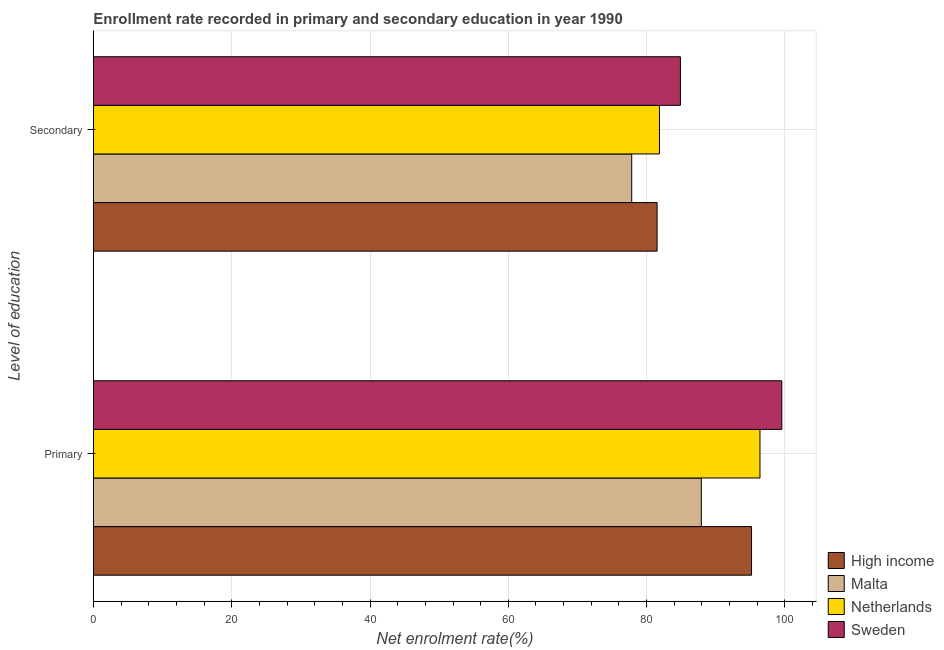How many different coloured bars are there?
Your answer should be compact. 4. Are the number of bars per tick equal to the number of legend labels?
Provide a short and direct response. Yes. Are the number of bars on each tick of the Y-axis equal?
Make the answer very short. Yes. How many bars are there on the 1st tick from the top?
Offer a terse response. 4. What is the label of the 2nd group of bars from the top?
Offer a terse response. Primary. What is the enrollment rate in primary education in Netherlands?
Keep it short and to the point. 96.4. Across all countries, what is the maximum enrollment rate in secondary education?
Provide a short and direct response. 84.89. Across all countries, what is the minimum enrollment rate in secondary education?
Offer a very short reply. 77.85. In which country was the enrollment rate in primary education maximum?
Your answer should be compact. Sweden. In which country was the enrollment rate in primary education minimum?
Provide a short and direct response. Malta. What is the total enrollment rate in primary education in the graph?
Offer a very short reply. 379.05. What is the difference between the enrollment rate in primary education in Malta and that in High income?
Provide a short and direct response. -7.27. What is the difference between the enrollment rate in primary education in High income and the enrollment rate in secondary education in Netherlands?
Provide a succinct answer. 13.32. What is the average enrollment rate in secondary education per country?
Give a very brief answer. 81.53. What is the difference between the enrollment rate in primary education and enrollment rate in secondary education in Malta?
Offer a terse response. 10.06. In how many countries, is the enrollment rate in secondary education greater than 68 %?
Make the answer very short. 4. What is the ratio of the enrollment rate in secondary education in High income to that in Sweden?
Make the answer very short. 0.96. Is the enrollment rate in secondary education in Malta less than that in High income?
Your response must be concise. Yes. In how many countries, is the enrollment rate in primary education greater than the average enrollment rate in primary education taken over all countries?
Ensure brevity in your answer.  3. What does the 1st bar from the bottom in Primary represents?
Your answer should be compact. High income. Are the values on the major ticks of X-axis written in scientific E-notation?
Offer a very short reply. No. Does the graph contain any zero values?
Give a very brief answer. No. Where does the legend appear in the graph?
Your answer should be very brief. Bottom right. How many legend labels are there?
Provide a short and direct response. 4. How are the legend labels stacked?
Make the answer very short. Vertical. What is the title of the graph?
Your answer should be very brief. Enrollment rate recorded in primary and secondary education in year 1990. Does "Bahamas" appear as one of the legend labels in the graph?
Your answer should be compact. No. What is the label or title of the X-axis?
Ensure brevity in your answer.  Net enrolment rate(%). What is the label or title of the Y-axis?
Make the answer very short. Level of education. What is the Net enrolment rate(%) of High income in Primary?
Keep it short and to the point. 95.18. What is the Net enrolment rate(%) of Malta in Primary?
Ensure brevity in your answer.  87.91. What is the Net enrolment rate(%) of Netherlands in Primary?
Your response must be concise. 96.4. What is the Net enrolment rate(%) in Sweden in Primary?
Provide a succinct answer. 99.56. What is the Net enrolment rate(%) in High income in Secondary?
Provide a succinct answer. 81.52. What is the Net enrolment rate(%) of Malta in Secondary?
Your answer should be very brief. 77.85. What is the Net enrolment rate(%) of Netherlands in Secondary?
Provide a succinct answer. 81.86. What is the Net enrolment rate(%) of Sweden in Secondary?
Your response must be concise. 84.89. Across all Level of education, what is the maximum Net enrolment rate(%) in High income?
Your answer should be compact. 95.18. Across all Level of education, what is the maximum Net enrolment rate(%) of Malta?
Provide a short and direct response. 87.91. Across all Level of education, what is the maximum Net enrolment rate(%) in Netherlands?
Your answer should be compact. 96.4. Across all Level of education, what is the maximum Net enrolment rate(%) in Sweden?
Your answer should be compact. 99.56. Across all Level of education, what is the minimum Net enrolment rate(%) in High income?
Offer a very short reply. 81.52. Across all Level of education, what is the minimum Net enrolment rate(%) in Malta?
Make the answer very short. 77.85. Across all Level of education, what is the minimum Net enrolment rate(%) of Netherlands?
Offer a very short reply. 81.86. Across all Level of education, what is the minimum Net enrolment rate(%) of Sweden?
Make the answer very short. 84.89. What is the total Net enrolment rate(%) in High income in the graph?
Offer a very short reply. 176.7. What is the total Net enrolment rate(%) of Malta in the graph?
Your answer should be compact. 165.76. What is the total Net enrolment rate(%) in Netherlands in the graph?
Ensure brevity in your answer.  178.26. What is the total Net enrolment rate(%) in Sweden in the graph?
Provide a succinct answer. 184.45. What is the difference between the Net enrolment rate(%) in High income in Primary and that in Secondary?
Provide a succinct answer. 13.66. What is the difference between the Net enrolment rate(%) of Malta in Primary and that in Secondary?
Your answer should be compact. 10.06. What is the difference between the Net enrolment rate(%) in Netherlands in Primary and that in Secondary?
Your answer should be compact. 14.54. What is the difference between the Net enrolment rate(%) of Sweden in Primary and that in Secondary?
Offer a very short reply. 14.66. What is the difference between the Net enrolment rate(%) of High income in Primary and the Net enrolment rate(%) of Malta in Secondary?
Offer a terse response. 17.33. What is the difference between the Net enrolment rate(%) of High income in Primary and the Net enrolment rate(%) of Netherlands in Secondary?
Provide a short and direct response. 13.32. What is the difference between the Net enrolment rate(%) in High income in Primary and the Net enrolment rate(%) in Sweden in Secondary?
Give a very brief answer. 10.29. What is the difference between the Net enrolment rate(%) in Malta in Primary and the Net enrolment rate(%) in Netherlands in Secondary?
Your answer should be very brief. 6.05. What is the difference between the Net enrolment rate(%) in Malta in Primary and the Net enrolment rate(%) in Sweden in Secondary?
Offer a terse response. 3.02. What is the difference between the Net enrolment rate(%) in Netherlands in Primary and the Net enrolment rate(%) in Sweden in Secondary?
Keep it short and to the point. 11.5. What is the average Net enrolment rate(%) of High income per Level of education?
Make the answer very short. 88.35. What is the average Net enrolment rate(%) of Malta per Level of education?
Provide a short and direct response. 82.88. What is the average Net enrolment rate(%) of Netherlands per Level of education?
Give a very brief answer. 89.13. What is the average Net enrolment rate(%) of Sweden per Level of education?
Your answer should be very brief. 92.23. What is the difference between the Net enrolment rate(%) in High income and Net enrolment rate(%) in Malta in Primary?
Make the answer very short. 7.27. What is the difference between the Net enrolment rate(%) in High income and Net enrolment rate(%) in Netherlands in Primary?
Keep it short and to the point. -1.22. What is the difference between the Net enrolment rate(%) in High income and Net enrolment rate(%) in Sweden in Primary?
Your answer should be very brief. -4.38. What is the difference between the Net enrolment rate(%) in Malta and Net enrolment rate(%) in Netherlands in Primary?
Ensure brevity in your answer.  -8.48. What is the difference between the Net enrolment rate(%) in Malta and Net enrolment rate(%) in Sweden in Primary?
Your response must be concise. -11.64. What is the difference between the Net enrolment rate(%) of Netherlands and Net enrolment rate(%) of Sweden in Primary?
Provide a succinct answer. -3.16. What is the difference between the Net enrolment rate(%) in High income and Net enrolment rate(%) in Malta in Secondary?
Your answer should be very brief. 3.67. What is the difference between the Net enrolment rate(%) of High income and Net enrolment rate(%) of Netherlands in Secondary?
Keep it short and to the point. -0.34. What is the difference between the Net enrolment rate(%) of High income and Net enrolment rate(%) of Sweden in Secondary?
Offer a terse response. -3.37. What is the difference between the Net enrolment rate(%) of Malta and Net enrolment rate(%) of Netherlands in Secondary?
Give a very brief answer. -4.01. What is the difference between the Net enrolment rate(%) of Malta and Net enrolment rate(%) of Sweden in Secondary?
Your response must be concise. -7.04. What is the difference between the Net enrolment rate(%) of Netherlands and Net enrolment rate(%) of Sweden in Secondary?
Ensure brevity in your answer.  -3.03. What is the ratio of the Net enrolment rate(%) in High income in Primary to that in Secondary?
Make the answer very short. 1.17. What is the ratio of the Net enrolment rate(%) in Malta in Primary to that in Secondary?
Give a very brief answer. 1.13. What is the ratio of the Net enrolment rate(%) in Netherlands in Primary to that in Secondary?
Give a very brief answer. 1.18. What is the ratio of the Net enrolment rate(%) of Sweden in Primary to that in Secondary?
Give a very brief answer. 1.17. What is the difference between the highest and the second highest Net enrolment rate(%) in High income?
Your answer should be very brief. 13.66. What is the difference between the highest and the second highest Net enrolment rate(%) of Malta?
Offer a very short reply. 10.06. What is the difference between the highest and the second highest Net enrolment rate(%) of Netherlands?
Make the answer very short. 14.54. What is the difference between the highest and the second highest Net enrolment rate(%) of Sweden?
Your answer should be compact. 14.66. What is the difference between the highest and the lowest Net enrolment rate(%) in High income?
Your answer should be very brief. 13.66. What is the difference between the highest and the lowest Net enrolment rate(%) of Malta?
Your answer should be very brief. 10.06. What is the difference between the highest and the lowest Net enrolment rate(%) in Netherlands?
Keep it short and to the point. 14.54. What is the difference between the highest and the lowest Net enrolment rate(%) in Sweden?
Give a very brief answer. 14.66. 